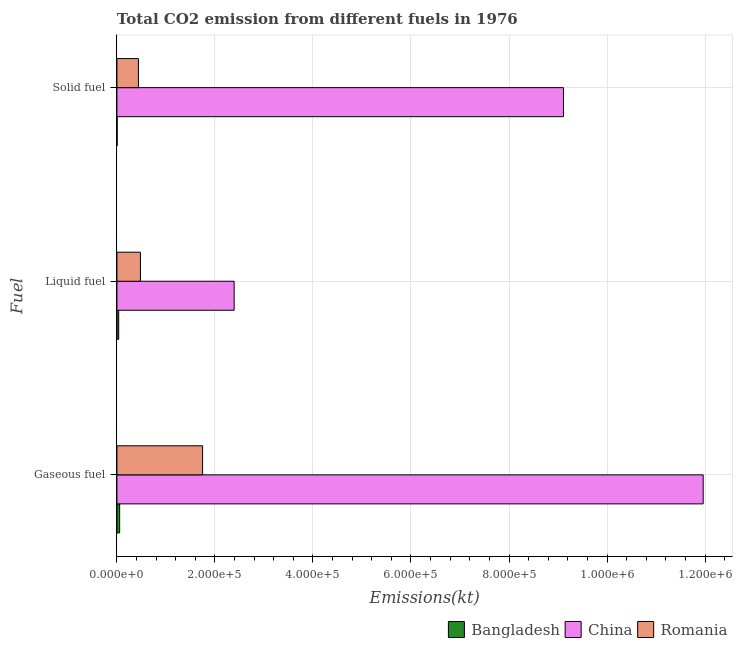Are the number of bars per tick equal to the number of legend labels?
Your response must be concise. Yes. Are the number of bars on each tick of the Y-axis equal?
Your answer should be very brief. Yes. How many bars are there on the 2nd tick from the top?
Provide a short and direct response. 3. What is the label of the 3rd group of bars from the top?
Your response must be concise. Gaseous fuel. What is the amount of co2 emissions from solid fuel in Bangladesh?
Offer a terse response. 447.37. Across all countries, what is the maximum amount of co2 emissions from solid fuel?
Keep it short and to the point. 9.11e+05. Across all countries, what is the minimum amount of co2 emissions from liquid fuel?
Offer a terse response. 3630.33. In which country was the amount of co2 emissions from gaseous fuel maximum?
Ensure brevity in your answer.  China. In which country was the amount of co2 emissions from solid fuel minimum?
Your answer should be compact. Bangladesh. What is the total amount of co2 emissions from liquid fuel in the graph?
Provide a succinct answer. 2.91e+05. What is the difference between the amount of co2 emissions from gaseous fuel in Romania and that in Bangladesh?
Provide a short and direct response. 1.69e+05. What is the difference between the amount of co2 emissions from gaseous fuel in Bangladesh and the amount of co2 emissions from solid fuel in China?
Your answer should be compact. -9.06e+05. What is the average amount of co2 emissions from liquid fuel per country?
Provide a short and direct response. 9.69e+04. What is the difference between the amount of co2 emissions from gaseous fuel and amount of co2 emissions from solid fuel in China?
Give a very brief answer. 2.85e+05. In how many countries, is the amount of co2 emissions from solid fuel greater than 120000 kt?
Give a very brief answer. 1. What is the ratio of the amount of co2 emissions from liquid fuel in China to that in Bangladesh?
Your answer should be very brief. 65.88. What is the difference between the highest and the second highest amount of co2 emissions from liquid fuel?
Keep it short and to the point. 1.91e+05. What is the difference between the highest and the lowest amount of co2 emissions from liquid fuel?
Keep it short and to the point. 2.36e+05. In how many countries, is the amount of co2 emissions from liquid fuel greater than the average amount of co2 emissions from liquid fuel taken over all countries?
Offer a very short reply. 1. What does the 1st bar from the top in Solid fuel represents?
Keep it short and to the point. Romania. What does the 3rd bar from the bottom in Gaseous fuel represents?
Your response must be concise. Romania. Are all the bars in the graph horizontal?
Your answer should be very brief. Yes. How many countries are there in the graph?
Your answer should be compact. 3. What is the difference between two consecutive major ticks on the X-axis?
Give a very brief answer. 2.00e+05. Does the graph contain any zero values?
Make the answer very short. No. How are the legend labels stacked?
Provide a short and direct response. Horizontal. What is the title of the graph?
Keep it short and to the point. Total CO2 emission from different fuels in 1976. What is the label or title of the X-axis?
Keep it short and to the point. Emissions(kt). What is the label or title of the Y-axis?
Provide a succinct answer. Fuel. What is the Emissions(kt) of Bangladesh in Gaseous fuel?
Give a very brief answer. 5570.17. What is the Emissions(kt) in China in Gaseous fuel?
Your answer should be very brief. 1.20e+06. What is the Emissions(kt) in Romania in Gaseous fuel?
Give a very brief answer. 1.75e+05. What is the Emissions(kt) of Bangladesh in Liquid fuel?
Provide a short and direct response. 3630.33. What is the Emissions(kt) of China in Liquid fuel?
Make the answer very short. 2.39e+05. What is the Emissions(kt) of Romania in Liquid fuel?
Provide a succinct answer. 4.80e+04. What is the Emissions(kt) of Bangladesh in Solid fuel?
Provide a succinct answer. 447.37. What is the Emissions(kt) in China in Solid fuel?
Ensure brevity in your answer.  9.11e+05. What is the Emissions(kt) in Romania in Solid fuel?
Your answer should be compact. 4.39e+04. Across all Fuel, what is the maximum Emissions(kt) in Bangladesh?
Ensure brevity in your answer.  5570.17. Across all Fuel, what is the maximum Emissions(kt) of China?
Make the answer very short. 1.20e+06. Across all Fuel, what is the maximum Emissions(kt) of Romania?
Give a very brief answer. 1.75e+05. Across all Fuel, what is the minimum Emissions(kt) of Bangladesh?
Provide a succinct answer. 447.37. Across all Fuel, what is the minimum Emissions(kt) of China?
Your answer should be very brief. 2.39e+05. Across all Fuel, what is the minimum Emissions(kt) in Romania?
Offer a very short reply. 4.39e+04. What is the total Emissions(kt) of Bangladesh in the graph?
Ensure brevity in your answer.  9647.88. What is the total Emissions(kt) of China in the graph?
Your answer should be compact. 2.35e+06. What is the total Emissions(kt) in Romania in the graph?
Provide a short and direct response. 2.67e+05. What is the difference between the Emissions(kt) of Bangladesh in Gaseous fuel and that in Liquid fuel?
Provide a short and direct response. 1939.84. What is the difference between the Emissions(kt) in China in Gaseous fuel and that in Liquid fuel?
Provide a succinct answer. 9.57e+05. What is the difference between the Emissions(kt) in Romania in Gaseous fuel and that in Liquid fuel?
Provide a succinct answer. 1.27e+05. What is the difference between the Emissions(kt) of Bangladesh in Gaseous fuel and that in Solid fuel?
Your response must be concise. 5122.8. What is the difference between the Emissions(kt) in China in Gaseous fuel and that in Solid fuel?
Make the answer very short. 2.85e+05. What is the difference between the Emissions(kt) of Romania in Gaseous fuel and that in Solid fuel?
Keep it short and to the point. 1.31e+05. What is the difference between the Emissions(kt) in Bangladesh in Liquid fuel and that in Solid fuel?
Your answer should be compact. 3182.96. What is the difference between the Emissions(kt) of China in Liquid fuel and that in Solid fuel?
Your answer should be very brief. -6.72e+05. What is the difference between the Emissions(kt) of Romania in Liquid fuel and that in Solid fuel?
Offer a very short reply. 4110.71. What is the difference between the Emissions(kt) of Bangladesh in Gaseous fuel and the Emissions(kt) of China in Liquid fuel?
Provide a succinct answer. -2.34e+05. What is the difference between the Emissions(kt) in Bangladesh in Gaseous fuel and the Emissions(kt) in Romania in Liquid fuel?
Ensure brevity in your answer.  -4.24e+04. What is the difference between the Emissions(kt) in China in Gaseous fuel and the Emissions(kt) in Romania in Liquid fuel?
Your answer should be compact. 1.15e+06. What is the difference between the Emissions(kt) in Bangladesh in Gaseous fuel and the Emissions(kt) in China in Solid fuel?
Give a very brief answer. -9.06e+05. What is the difference between the Emissions(kt) in Bangladesh in Gaseous fuel and the Emissions(kt) in Romania in Solid fuel?
Ensure brevity in your answer.  -3.83e+04. What is the difference between the Emissions(kt) in China in Gaseous fuel and the Emissions(kt) in Romania in Solid fuel?
Your answer should be compact. 1.15e+06. What is the difference between the Emissions(kt) of Bangladesh in Liquid fuel and the Emissions(kt) of China in Solid fuel?
Give a very brief answer. -9.08e+05. What is the difference between the Emissions(kt) of Bangladesh in Liquid fuel and the Emissions(kt) of Romania in Solid fuel?
Keep it short and to the point. -4.02e+04. What is the difference between the Emissions(kt) of China in Liquid fuel and the Emissions(kt) of Romania in Solid fuel?
Provide a succinct answer. 1.95e+05. What is the average Emissions(kt) in Bangladesh per Fuel?
Provide a short and direct response. 3215.96. What is the average Emissions(kt) of China per Fuel?
Keep it short and to the point. 7.82e+05. What is the average Emissions(kt) in Romania per Fuel?
Your answer should be very brief. 8.89e+04. What is the difference between the Emissions(kt) in Bangladesh and Emissions(kt) in China in Gaseous fuel?
Offer a terse response. -1.19e+06. What is the difference between the Emissions(kt) of Bangladesh and Emissions(kt) of Romania in Gaseous fuel?
Make the answer very short. -1.69e+05. What is the difference between the Emissions(kt) in China and Emissions(kt) in Romania in Gaseous fuel?
Make the answer very short. 1.02e+06. What is the difference between the Emissions(kt) in Bangladesh and Emissions(kt) in China in Liquid fuel?
Provide a succinct answer. -2.36e+05. What is the difference between the Emissions(kt) in Bangladesh and Emissions(kt) in Romania in Liquid fuel?
Ensure brevity in your answer.  -4.44e+04. What is the difference between the Emissions(kt) in China and Emissions(kt) in Romania in Liquid fuel?
Offer a terse response. 1.91e+05. What is the difference between the Emissions(kt) in Bangladesh and Emissions(kt) in China in Solid fuel?
Your response must be concise. -9.11e+05. What is the difference between the Emissions(kt) of Bangladesh and Emissions(kt) of Romania in Solid fuel?
Your response must be concise. -4.34e+04. What is the difference between the Emissions(kt) in China and Emissions(kt) in Romania in Solid fuel?
Your response must be concise. 8.67e+05. What is the ratio of the Emissions(kt) in Bangladesh in Gaseous fuel to that in Liquid fuel?
Ensure brevity in your answer.  1.53. What is the ratio of the Emissions(kt) in China in Gaseous fuel to that in Liquid fuel?
Give a very brief answer. 5. What is the ratio of the Emissions(kt) of Romania in Gaseous fuel to that in Liquid fuel?
Make the answer very short. 3.64. What is the ratio of the Emissions(kt) in Bangladesh in Gaseous fuel to that in Solid fuel?
Provide a succinct answer. 12.45. What is the ratio of the Emissions(kt) in China in Gaseous fuel to that in Solid fuel?
Offer a very short reply. 1.31. What is the ratio of the Emissions(kt) in Romania in Gaseous fuel to that in Solid fuel?
Provide a short and direct response. 3.98. What is the ratio of the Emissions(kt) of Bangladesh in Liquid fuel to that in Solid fuel?
Your answer should be very brief. 8.11. What is the ratio of the Emissions(kt) of China in Liquid fuel to that in Solid fuel?
Your answer should be very brief. 0.26. What is the ratio of the Emissions(kt) in Romania in Liquid fuel to that in Solid fuel?
Ensure brevity in your answer.  1.09. What is the difference between the highest and the second highest Emissions(kt) in Bangladesh?
Keep it short and to the point. 1939.84. What is the difference between the highest and the second highest Emissions(kt) of China?
Make the answer very short. 2.85e+05. What is the difference between the highest and the second highest Emissions(kt) of Romania?
Make the answer very short. 1.27e+05. What is the difference between the highest and the lowest Emissions(kt) of Bangladesh?
Offer a terse response. 5122.8. What is the difference between the highest and the lowest Emissions(kt) of China?
Your answer should be compact. 9.57e+05. What is the difference between the highest and the lowest Emissions(kt) of Romania?
Keep it short and to the point. 1.31e+05. 